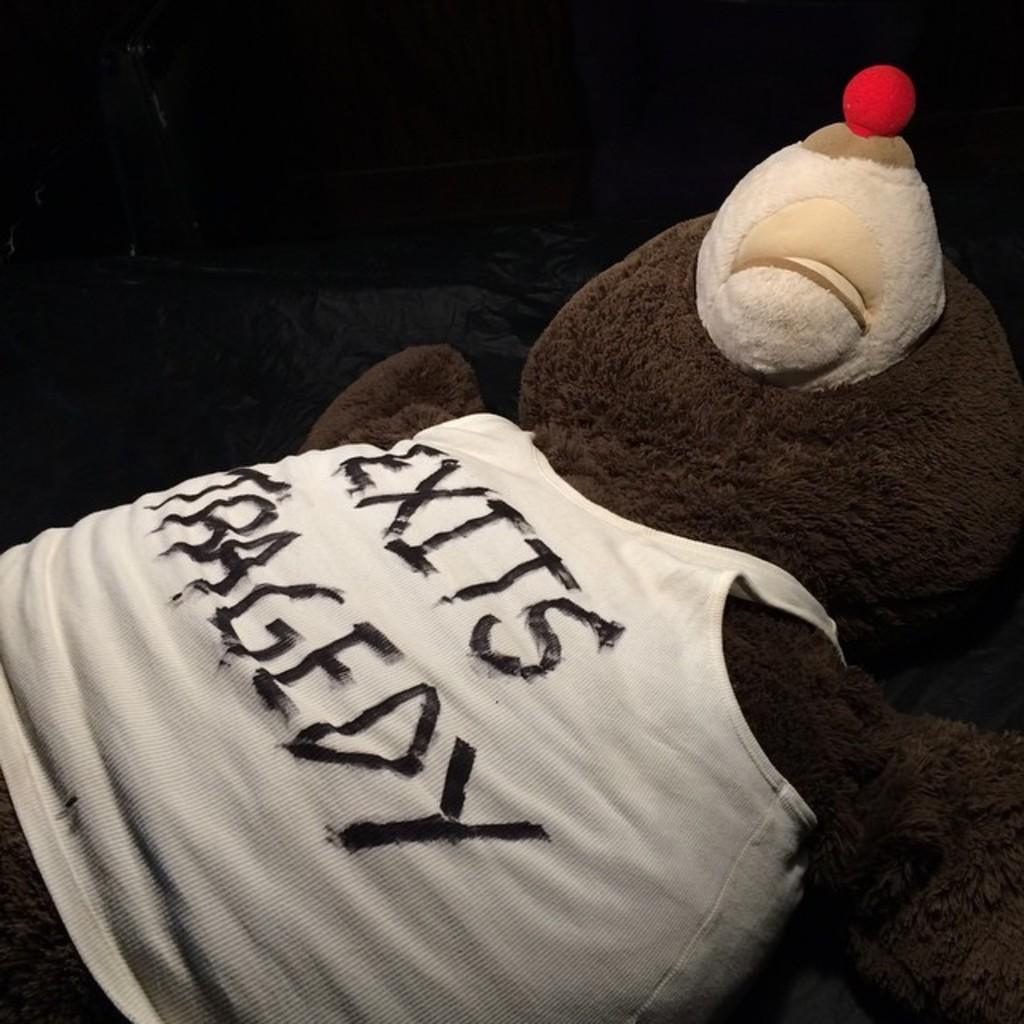What type of object is in the image? A: There is a teddy bear in the image. How is the teddy bear positioned in the image? The teddy bear is in a lying position. Is there any text or writing on the teddy bear? Yes, the word "EXIST" is written on the teddy bear. What type of root can be seen growing from the teddy bear in the image? There is no root growing from the teddy bear in the image. Is there a porter carrying luggage in the image? There is no porter or luggage present in the image. 